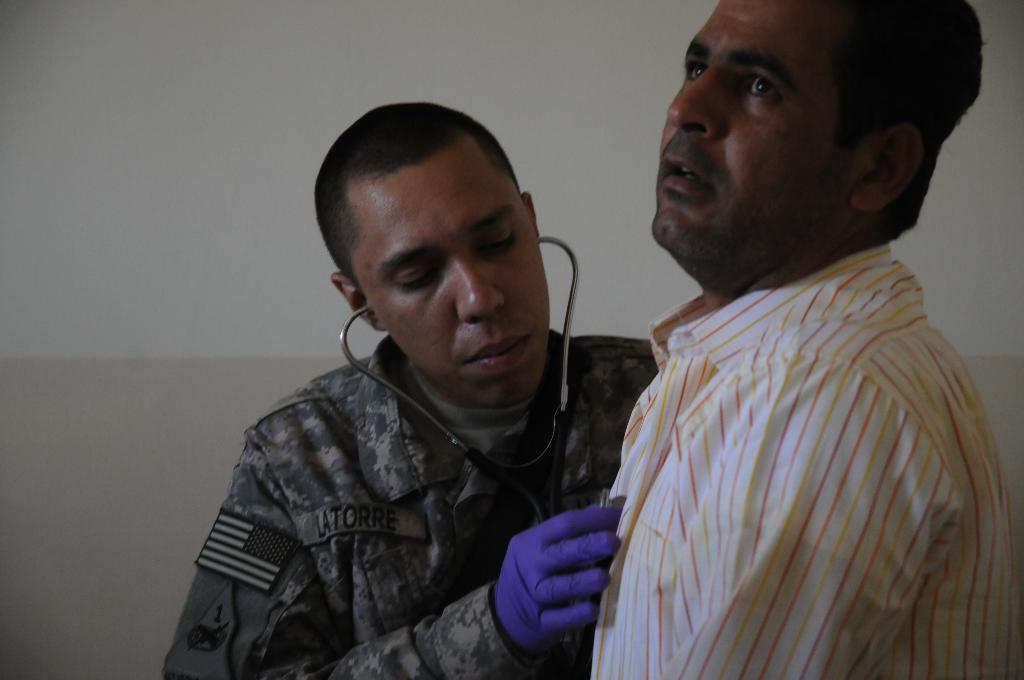What is the color of the wall in the image? The wall in the image is white. How many people are in the image? There are two people in the image. What is the position of one of the people in the image? One person is standing in the middle. What object is the person standing in the middle holding? The person standing in the middle is holding a stethoscope in his hand. What sound does the thunder make in the image? There is no thunder present in the image. What is the reaction of the people when they are surprised in the image? There is no indication of surprise in the image. 